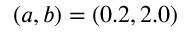Convert formula to latex. <formula><loc_0><loc_0><loc_500><loc_500>( a , b ) = ( 0 . 2 , 2 . 0 )</formula> 